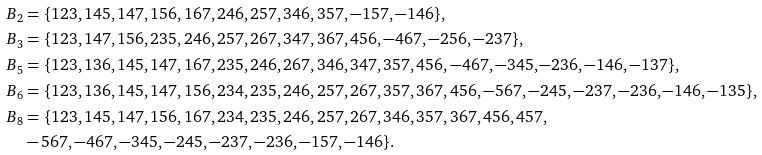Convert formula to latex. <formula><loc_0><loc_0><loc_500><loc_500>\ B _ { 2 } & = \{ 1 2 3 , 1 4 5 , 1 4 7 , 1 5 6 , 1 6 7 , 2 4 6 , 2 5 7 , 3 4 6 , 3 5 7 , - 1 5 7 , - 1 4 6 \} , \\ \ B _ { 3 } & = \{ 1 2 3 , 1 4 7 , 1 5 6 , 2 3 5 , 2 4 6 , 2 5 7 , 2 6 7 , 3 4 7 , 3 6 7 , 4 5 6 , - 4 6 7 , - 2 5 6 , - 2 3 7 \} , \\ \ B _ { 5 } & = \{ 1 2 3 , 1 3 6 , 1 4 5 , 1 4 7 , 1 6 7 , 2 3 5 , 2 4 6 , 2 6 7 , 3 4 6 , 3 4 7 , 3 5 7 , 4 5 6 , - 4 6 7 , - 3 4 5 , - 2 3 6 , - 1 4 6 , - 1 3 7 \} , \\ \ B _ { 6 } & = \{ 1 2 3 , 1 3 6 , 1 4 5 , 1 4 7 , 1 5 6 , 2 3 4 , 2 3 5 , 2 4 6 , 2 5 7 , 2 6 7 , 3 5 7 , 3 6 7 , 4 5 6 , - 5 6 7 , - 2 4 5 , - 2 3 7 , - 2 3 6 , - 1 4 6 , - 1 3 5 \} , \\ \ B _ { 8 } & = \{ 1 2 3 , 1 4 5 , 1 4 7 , 1 5 6 , 1 6 7 , 2 3 4 , 2 3 5 , 2 4 6 , 2 5 7 , 2 6 7 , 3 4 6 , 3 5 7 , 3 6 7 , 4 5 6 , 4 5 7 , \\ & - 5 6 7 , - 4 6 7 , - 3 4 5 , - 2 4 5 , - 2 3 7 , - 2 3 6 , - 1 5 7 , - 1 4 6 \} .</formula> 